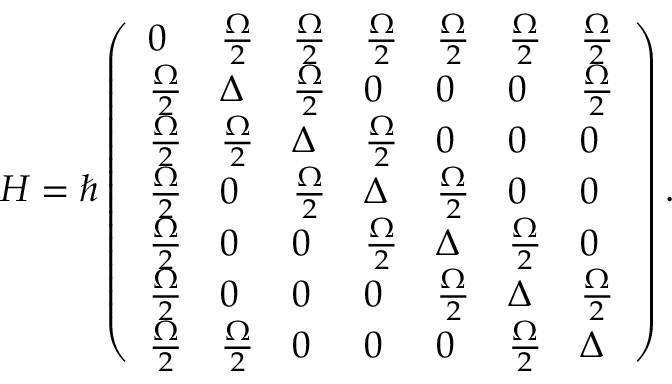<formula> <loc_0><loc_0><loc_500><loc_500>H = \hbar { \left } ( \begin{array} { l l l l l l l } { 0 } & { \frac { \Omega } { 2 } } & { \frac { \Omega } { 2 } } & { \frac { \Omega } { 2 } } & { \frac { \Omega } { 2 } } & { \frac { \Omega } { 2 } } & { \frac { \Omega } { 2 } } \\ { \frac { \Omega } { 2 } } & { \Delta } & { \frac { \Omega } { 2 } } & { 0 } & { 0 } & { 0 } & { \frac { \Omega } { 2 } } \\ { \frac { \Omega } { 2 } } & { \frac { \Omega } { 2 } } & { \Delta } & { \frac { \Omega } { 2 } } & { 0 } & { 0 } & { 0 } \\ { \frac { \Omega } { 2 } } & { 0 } & { \frac { \Omega } { 2 } } & { \Delta } & { \frac { \Omega } { 2 } } & { 0 } & { 0 } \\ { \frac { \Omega } { 2 } } & { 0 } & { 0 } & { \frac { \Omega } { 2 } } & { \Delta } & { \frac { \Omega } { 2 } } & { 0 } \\ { \frac { \Omega } { 2 } } & { 0 } & { 0 } & { 0 } & { \frac { \Omega } { 2 } } & { \Delta } & { \frac { \Omega } { 2 } } \\ { \frac { \Omega } { 2 } } & { \frac { \Omega } { 2 } } & { 0 } & { 0 } & { 0 } & { \frac { \Omega } { 2 } } & { \Delta } \end{array} \right ) .</formula> 